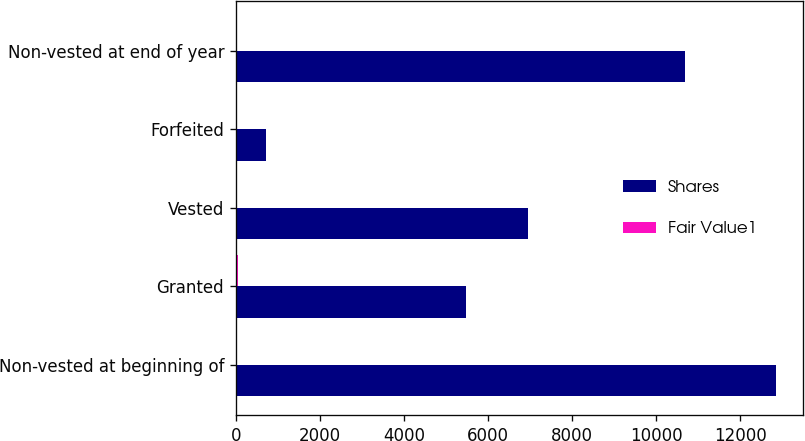<chart> <loc_0><loc_0><loc_500><loc_500><stacked_bar_chart><ecel><fcel>Non-vested at beginning of<fcel>Granted<fcel>Vested<fcel>Forfeited<fcel>Non-vested at end of year<nl><fcel>Shares<fcel>12850<fcel>5477<fcel>6938<fcel>715<fcel>10674<nl><fcel>Fair Value1<fcel>36<fcel>39<fcel>35<fcel>35<fcel>38<nl></chart> 